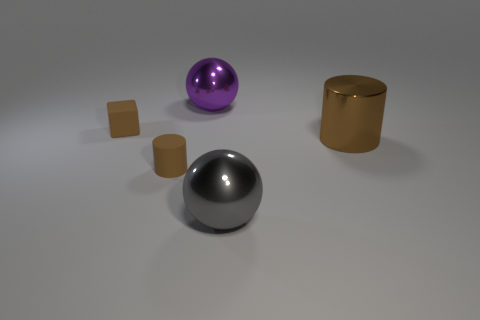Add 4 tiny cylinders. How many objects exist? 9 Subtract all gray balls. How many balls are left? 1 Subtract all spheres. How many objects are left? 3 Add 1 large brown shiny objects. How many large brown shiny objects are left? 2 Add 2 gray metal spheres. How many gray metal spheres exist? 3 Subtract 0 blue cylinders. How many objects are left? 5 Subtract 1 balls. How many balls are left? 1 Subtract all red cubes. Subtract all red spheres. How many cubes are left? 1 Subtract all red metal cylinders. Subtract all small cylinders. How many objects are left? 4 